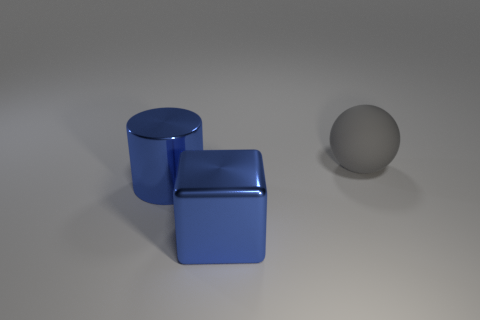Is there anything notable about the composition of this image? The composition of the image is quite minimalist, with a strong emphasis on geometric shapes, clean lines, and a limited color palette that draws attention to the forms and positions of the objects. 